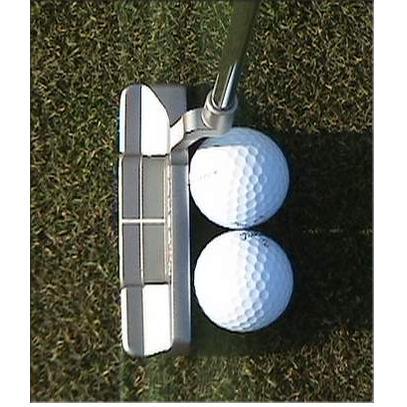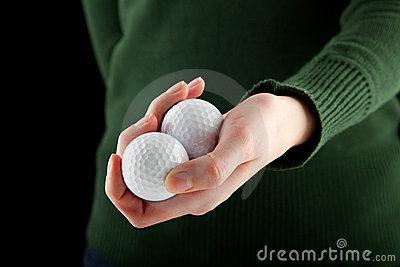The first image is the image on the left, the second image is the image on the right. Considering the images on both sides, is "One of the images contains a golf tee touching a golf ball on the ground." valid? Answer yes or no. No. 